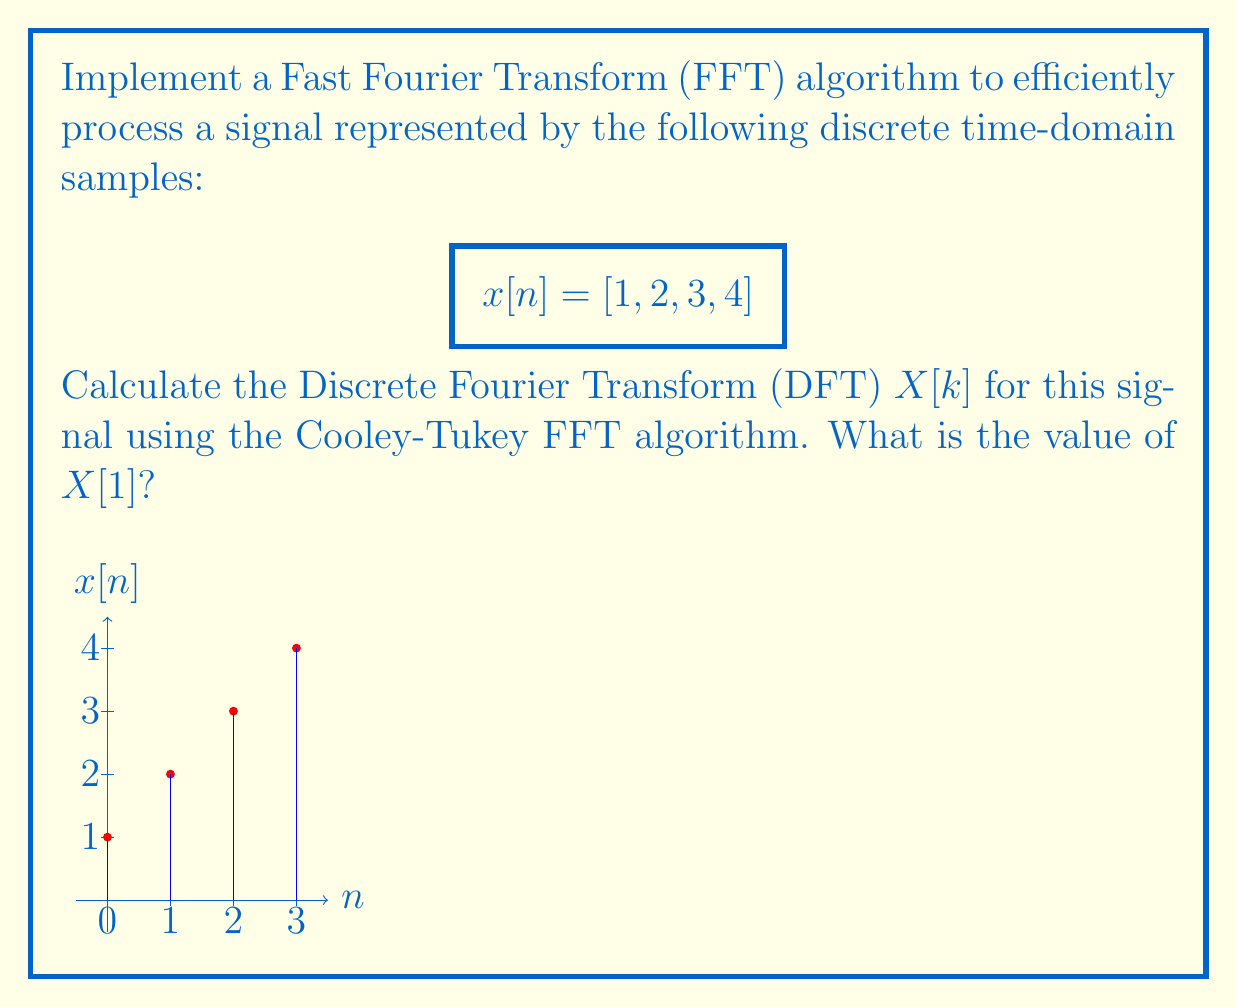Can you solve this math problem? To calculate the DFT using the Cooley-Tukey FFT algorithm for the given signal $x[n] = [1, 2, 3, 4]$, we'll follow these steps:

1) The FFT algorithm works most efficiently with signals whose length is a power of 2. Our signal has 4 samples, which is $2^2$, so we can proceed without zero-padding.

2) The Cooley-Tukey FFT algorithm uses the divide-and-conquer approach. For a 4-point FFT, we'll split the signal into two 2-point DFTs and combine them.

3) Let's split the signal into even and odd indexed samples:
   $x_{even}[n] = [x[0], x[2]] = [1, 3]$
   $x_{odd}[n] = [x[1], x[3]] = [2, 4]$

4) Calculate 2-point DFTs for each:
   For $x_{even}$: 
   $X_{even}[0] = 1 + 3 = 4$
   $X_{even}[1] = 1 - 3 = -2$

   For $x_{odd}$:
   $X_{odd}[0] = 2 + 4 = 6$
   $X_{odd}[1] = 2 - 4 = -2$

5) Now, we combine these results using the FFT butterfly operation:
   $X[k] = X_{even}[k] + W_N^k X_{odd}[k]$
   $X[k+N/2] = X_{even}[k] - W_N^k X_{odd}[k]$

   Where $W_N^k = e^{-j2\pi k/N}$ are the twiddle factors.

6) For $N=4$, we need to calculate:
   $W_4^0 = 1$
   $W_4^1 = e^{-j\pi/2} = -j$

7) Now, let's combine:
   $X[0] = X_{even}[0] + W_4^0 X_{odd}[0] = 4 + 1 * 6 = 10$
   $X[1] = X_{even}[1] + W_4^1 X_{odd}[1] = -2 + (-j) * (-2) = -2 + 2j$
   $X[2] = X_{even}[0] - W_4^0 X_{odd}[0] = 4 - 1 * 6 = -2$
   $X[3] = X_{even}[1] - W_4^1 X_{odd}[1] = -2 - (-j) * (-2) = -2 - 2j$

8) The question asks for $X[1]$, which we calculated as $-2 + 2j$.
Answer: $-2 + 2j$ 